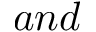Convert formula to latex. <formula><loc_0><loc_0><loc_500><loc_500>a n d</formula> 